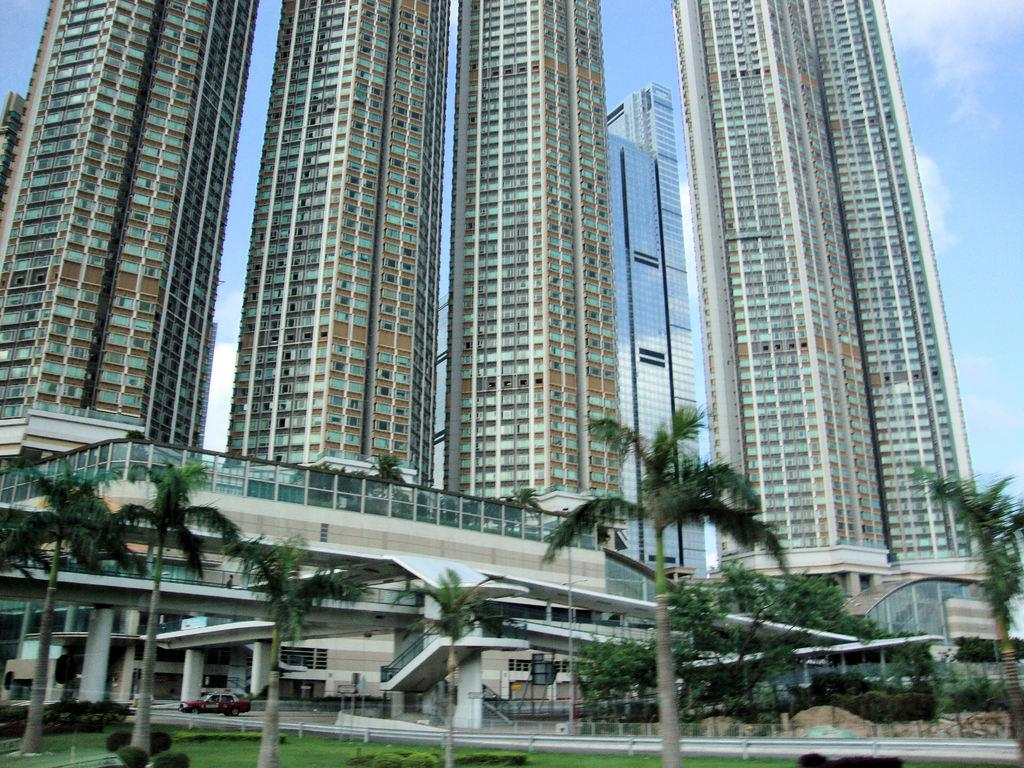What type of vegetation is visible in the image? There are trees in the image. What architectural feature can be seen in the image? There are stairs in the image. What type of structures are present in the image? There are buildings in the image. What type of juice can be seen being poured in the image? There is no juice present in the image. What type of light source is visible in the image? There is no specific light source visible in the image. What is the person in the image rubbing on their hands? There is no person or rubbing action present in the image. 